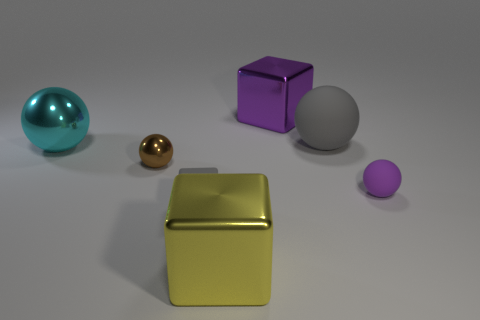Do the large yellow thing and the tiny ball that is on the right side of the small brown sphere have the same material?
Give a very brief answer. No. What color is the large ball that is to the left of the tiny rubber thing that is left of the block that is in front of the tiny gray cube?
Keep it short and to the point. Cyan. There is a brown metal object that is the same size as the purple rubber object; what shape is it?
Make the answer very short. Sphere. Is the size of the shiny thing to the right of the large yellow metal object the same as the rubber sphere in front of the large gray rubber thing?
Offer a very short reply. No. What is the size of the cube that is to the left of the big yellow shiny cube?
Offer a very short reply. Small. What is the material of the small cube that is the same color as the big rubber thing?
Make the answer very short. Rubber. The shiny ball that is the same size as the gray rubber block is what color?
Provide a succinct answer. Brown. Is the cyan shiny ball the same size as the yellow cube?
Give a very brief answer. Yes. How big is the sphere that is both to the left of the purple rubber object and right of the tiny metal thing?
Provide a succinct answer. Large. How many rubber objects are either spheres or big things?
Keep it short and to the point. 2. 